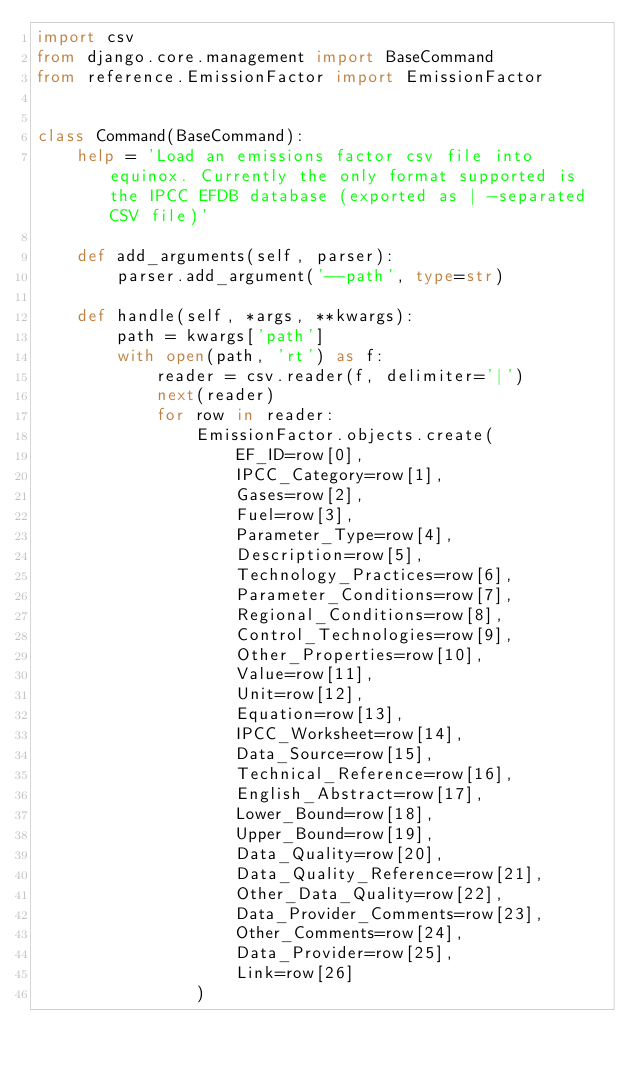Convert code to text. <code><loc_0><loc_0><loc_500><loc_500><_Python_>import csv
from django.core.management import BaseCommand
from reference.EmissionFactor import EmissionFactor


class Command(BaseCommand):
    help = 'Load an emissions factor csv file into equinox. Currently the only format supported is the IPCC EFDB database (exported as | -separated CSV file)'

    def add_arguments(self, parser):
        parser.add_argument('--path', type=str)

    def handle(self, *args, **kwargs):
        path = kwargs['path']
        with open(path, 'rt') as f:
            reader = csv.reader(f, delimiter='|')
            next(reader)
            for row in reader:
                EmissionFactor.objects.create(
                    EF_ID=row[0],
                    IPCC_Category=row[1],
                    Gases=row[2],
                    Fuel=row[3],
                    Parameter_Type=row[4],
                    Description=row[5],
                    Technology_Practices=row[6],
                    Parameter_Conditions=row[7],
                    Regional_Conditions=row[8],
                    Control_Technologies=row[9],
                    Other_Properties=row[10],
                    Value=row[11],
                    Unit=row[12],
                    Equation=row[13],
                    IPCC_Worksheet=row[14],
                    Data_Source=row[15],
                    Technical_Reference=row[16],
                    English_Abstract=row[17],
                    Lower_Bound=row[18],
                    Upper_Bound=row[19],
                    Data_Quality=row[20],
                    Data_Quality_Reference=row[21],
                    Other_Data_Quality=row[22],
                    Data_Provider_Comments=row[23],
                    Other_Comments=row[24],
                    Data_Provider=row[25],
                    Link=row[26]
                )
</code> 